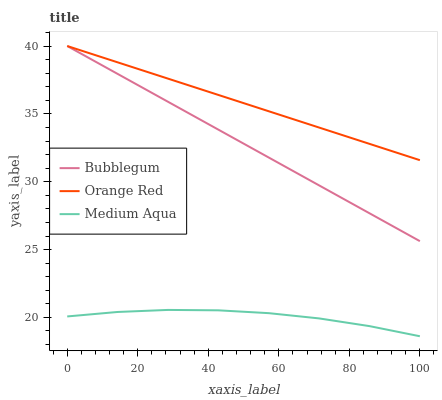Does Medium Aqua have the minimum area under the curve?
Answer yes or no. Yes. Does Orange Red have the maximum area under the curve?
Answer yes or no. Yes. Does Bubblegum have the minimum area under the curve?
Answer yes or no. No. Does Bubblegum have the maximum area under the curve?
Answer yes or no. No. Is Orange Red the smoothest?
Answer yes or no. Yes. Is Medium Aqua the roughest?
Answer yes or no. Yes. Is Bubblegum the smoothest?
Answer yes or no. No. Is Bubblegum the roughest?
Answer yes or no. No. Does Medium Aqua have the lowest value?
Answer yes or no. Yes. Does Bubblegum have the lowest value?
Answer yes or no. No. Does Bubblegum have the highest value?
Answer yes or no. Yes. Is Medium Aqua less than Orange Red?
Answer yes or no. Yes. Is Orange Red greater than Medium Aqua?
Answer yes or no. Yes. Does Bubblegum intersect Orange Red?
Answer yes or no. Yes. Is Bubblegum less than Orange Red?
Answer yes or no. No. Is Bubblegum greater than Orange Red?
Answer yes or no. No. Does Medium Aqua intersect Orange Red?
Answer yes or no. No. 